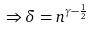<formula> <loc_0><loc_0><loc_500><loc_500>\Rightarrow \delta = n ^ { \gamma - \frac { 1 } { 2 } }</formula> 